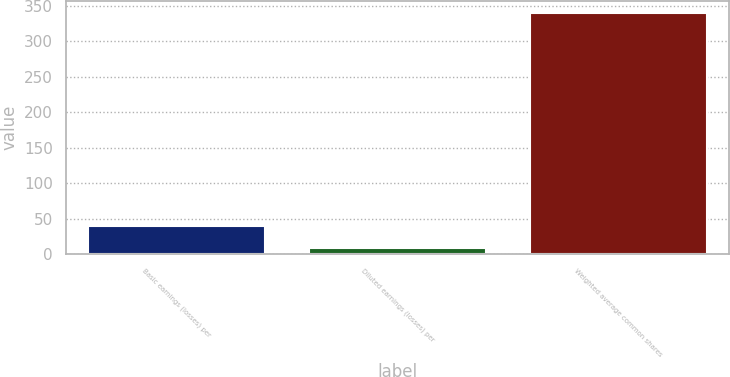Convert chart to OTSL. <chart><loc_0><loc_0><loc_500><loc_500><bar_chart><fcel>Basic earnings (losses) per<fcel>Diluted earnings (losses) per<fcel>Weighted average common shares<nl><fcel>39.41<fcel>8.69<fcel>339.52<nl></chart> 